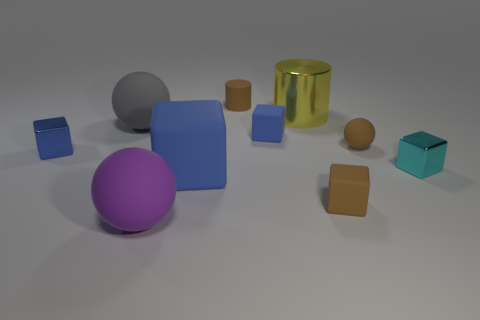How many blue blocks must be subtracted to get 1 blue blocks? 2 Subtract all tiny blue matte cubes. How many cubes are left? 4 Subtract all cyan cubes. How many cubes are left? 4 Subtract all cylinders. How many objects are left? 8 Subtract 1 spheres. How many spheres are left? 2 Subtract all green balls. How many blue cylinders are left? 0 Add 8 large yellow metal objects. How many large yellow metal objects are left? 9 Add 2 blocks. How many blocks exist? 7 Subtract 0 gray cylinders. How many objects are left? 10 Subtract all yellow blocks. Subtract all blue cylinders. How many blocks are left? 5 